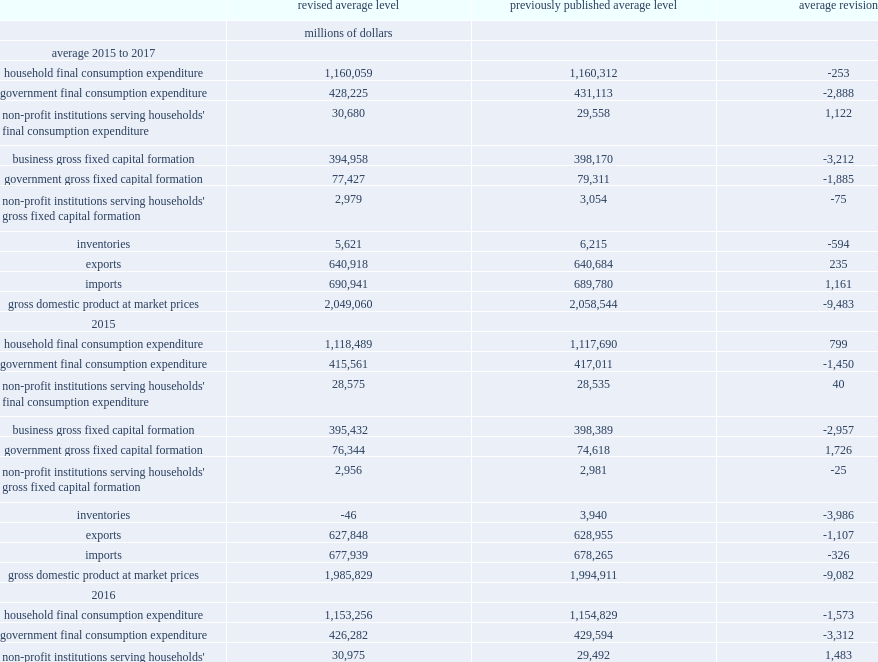Would you mind parsing the complete table? {'header': ['', 'revised average level', 'previously published average level', 'average revision'], 'rows': [['', 'millions of dollars', '', ''], ['average 2015 to 2017', '', '', ''], ['household final consumption expenditure', '1,160,059', '1,160,312', '-253'], ['government final consumption expenditure', '428,225', '431,113', '-2,888'], ["non-profit institutions serving households' final consumption expenditure", '30,680', '29,558', '1,122'], ['business gross fixed capital formation', '394,958', '398,170', '-3,212'], ['government gross fixed capital formation', '77,427', '79,311', '-1,885'], ["non-profit institutions serving households' gross fixed capital formation", '2,979', '3,054', '-75'], ['inventories', '5,621', '6,215', '-594'], ['exports', '640,918', '640,684', '235'], ['imports', '690,941', '689,780', '1,161'], ['gross domestic product at market prices', '2,049,060', '2,058,544', '-9,483'], ['2015', '', '', ''], ['household final consumption expenditure', '1,118,489', '1,117,690', '799'], ['government final consumption expenditure', '415,561', '417,011', '-1,450'], ["non-profit institutions serving households' final consumption expenditure", '28,575', '28,535', '40'], ['business gross fixed capital formation', '395,432', '398,389', '-2,957'], ['government gross fixed capital formation', '76,344', '74,618', '1,726'], ["non-profit institutions serving households' gross fixed capital formation", '2,956', '2,981', '-25'], ['inventories', '-46', '3,940', '-3,986'], ['exports', '627,848', '628,955', '-1,107'], ['imports', '677,939', '678,265', '-326'], ['gross domestic product at market prices', '1,985,829', '1,994,911', '-9,082'], ['2016', '', '', ''], ['household final consumption expenditure', '1,153,256', '1,154,829', '-1,573'], ['government final consumption expenditure', '426,282', '429,594', '-3,312'], ["non-profit institutions serving households' final consumption expenditure", '30,975', '29,492', '1,483'], ['business gross fixed capital formation', '386,668', '389,592', '-2,924'], ['government gross fixed capital formation', '75,064', '79,762', '-4,698'], ["non-profit institutions serving households' gross fixed capital formation", '2,905', '3,065', '-160'], ['inventories', '-606', '-487', '-119'], ['exports', '631,229', '630,353', '876'], ['imports', '680,791', '679,538', '1,253'], ['gross domestic product at market prices', '2,023,824', '2,035,506', '-11,682'], ['2017', '', '', ''], ['household final consumption expenditure', '1,208,432', '1,208,417', '15'], ['government final consumption expenditure', '442,831', '446,734', '-3,903'], ["non-profit institutions serving households' final consumption expenditure", '32,490', '30,647', '1,843'], ['business gross fixed capital formation', '402,774', '406,528', '-3,754'], ['government gross fixed capital formation', '80,872', '83,554', '-2,682'], ["non-profit institutions serving households' gross fixed capital formation", '3,077', '3,117', '-40'], ['inventories', '17,515', '15,192', '2,323'], ['exports', '663,678', '662,743', '935'], ['imports', '714,094', '711,538', '2,556'], ['gross domestic product at market prices', '2,137,528', '2,145,214', '-7,686']]} How many millions of dollars have the estimates for household final consumption expenditure been revised upward in 2015? 799.0. How many millions of dollars have the estimates for household final consumption expenditure been revised down in 2016? 1573. How many millions of dollars have government final consumption expenditures been revised to a lower level than previously in 2015? -1450.0. How many millions of dollars have government final consumption expenditures been revised to a lower level than previously in 2015? -3312.0. How many millions of dollars have government final consumption expenditures been revised to a lower level than previously in 2015? -3903.0. How many millions of dollars were the revisions to business gross fixed capital formation in 2015? -2957.0. How many millions of dollars were the revisions to business gross fixed capital formation in 2016? -2924.0. How many millions of dollars were the revisions to business gross fixed capital formation in 2017? -3754.0. How many millions of dollars have general government gross fixed capital formationin been increased in 2015? 1726.0. How many millions of dollars have general government gross fixed capital formationin been decreased in 2016? 4698. How many millions of dollars have the revisions to estimates of business inventories been decreased in 2015? -40. How many millions of dollars have exports of goods and services been revised down in 2015? 1107. How many millions of dollars have exports of goods and services been revised down in 2016? 876.0. How many millions of dollars have exports of goods and services been revised down in 2017? 935.0. How many millions of dollars have the revisions to estimates of business inventories been increased in 2016? 1253.0. How many millions of dollars have the revisions to estimates of business inventories been increased in 2017? 2556.0. 